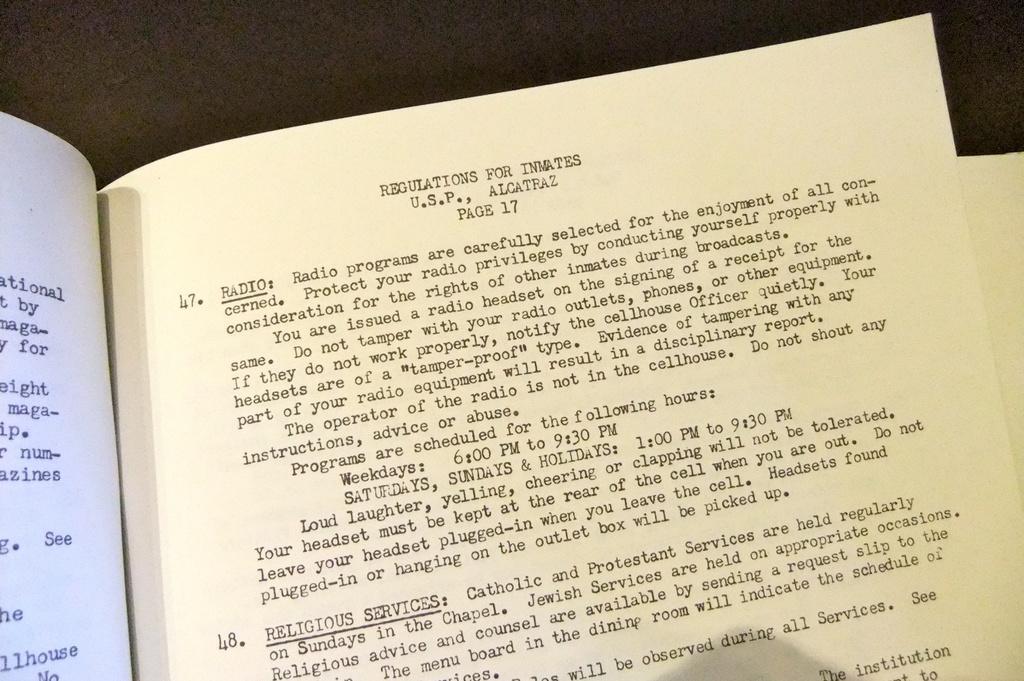How would you summarize this image in a sentence or two? In this picture we can see the pages of a book with matter printed on it. 